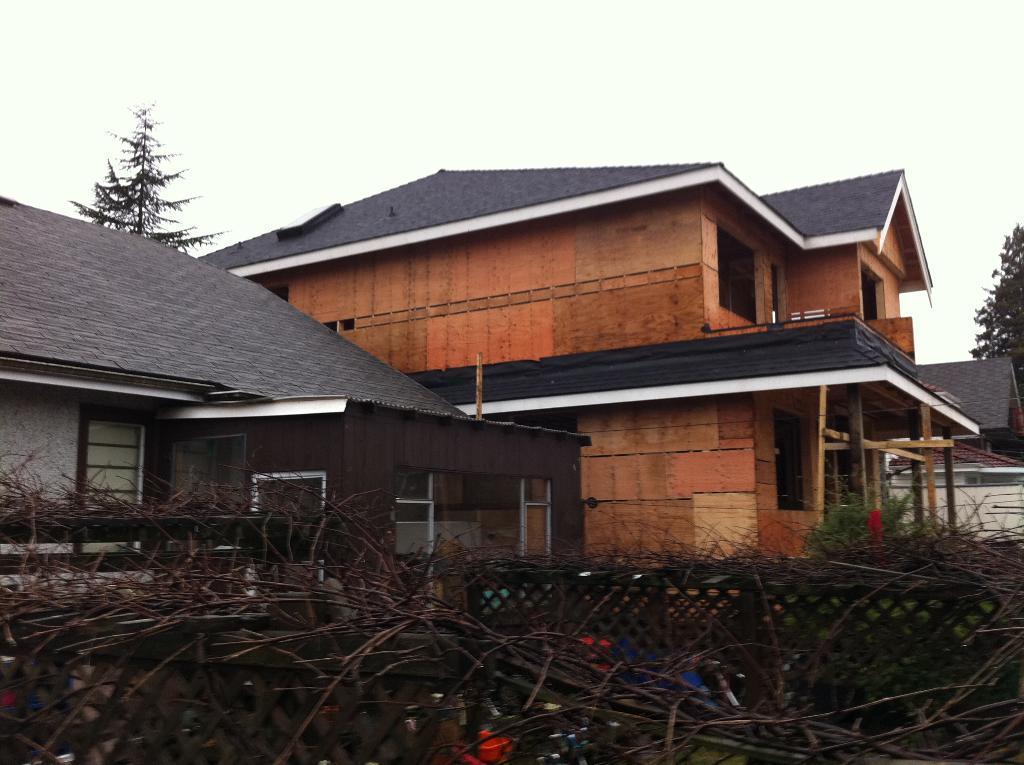Could you give a brief overview of what you see in this image? At the bottom of the picture, we see the wooden sticks, twigs and the fence. In the middle, we see the objects in red and blue color. In the middle, we see the buildings with the grey color roof. Behind that, we see a tree. On the right side, we see a tree and a building in white color. At the top, we see the sky. 